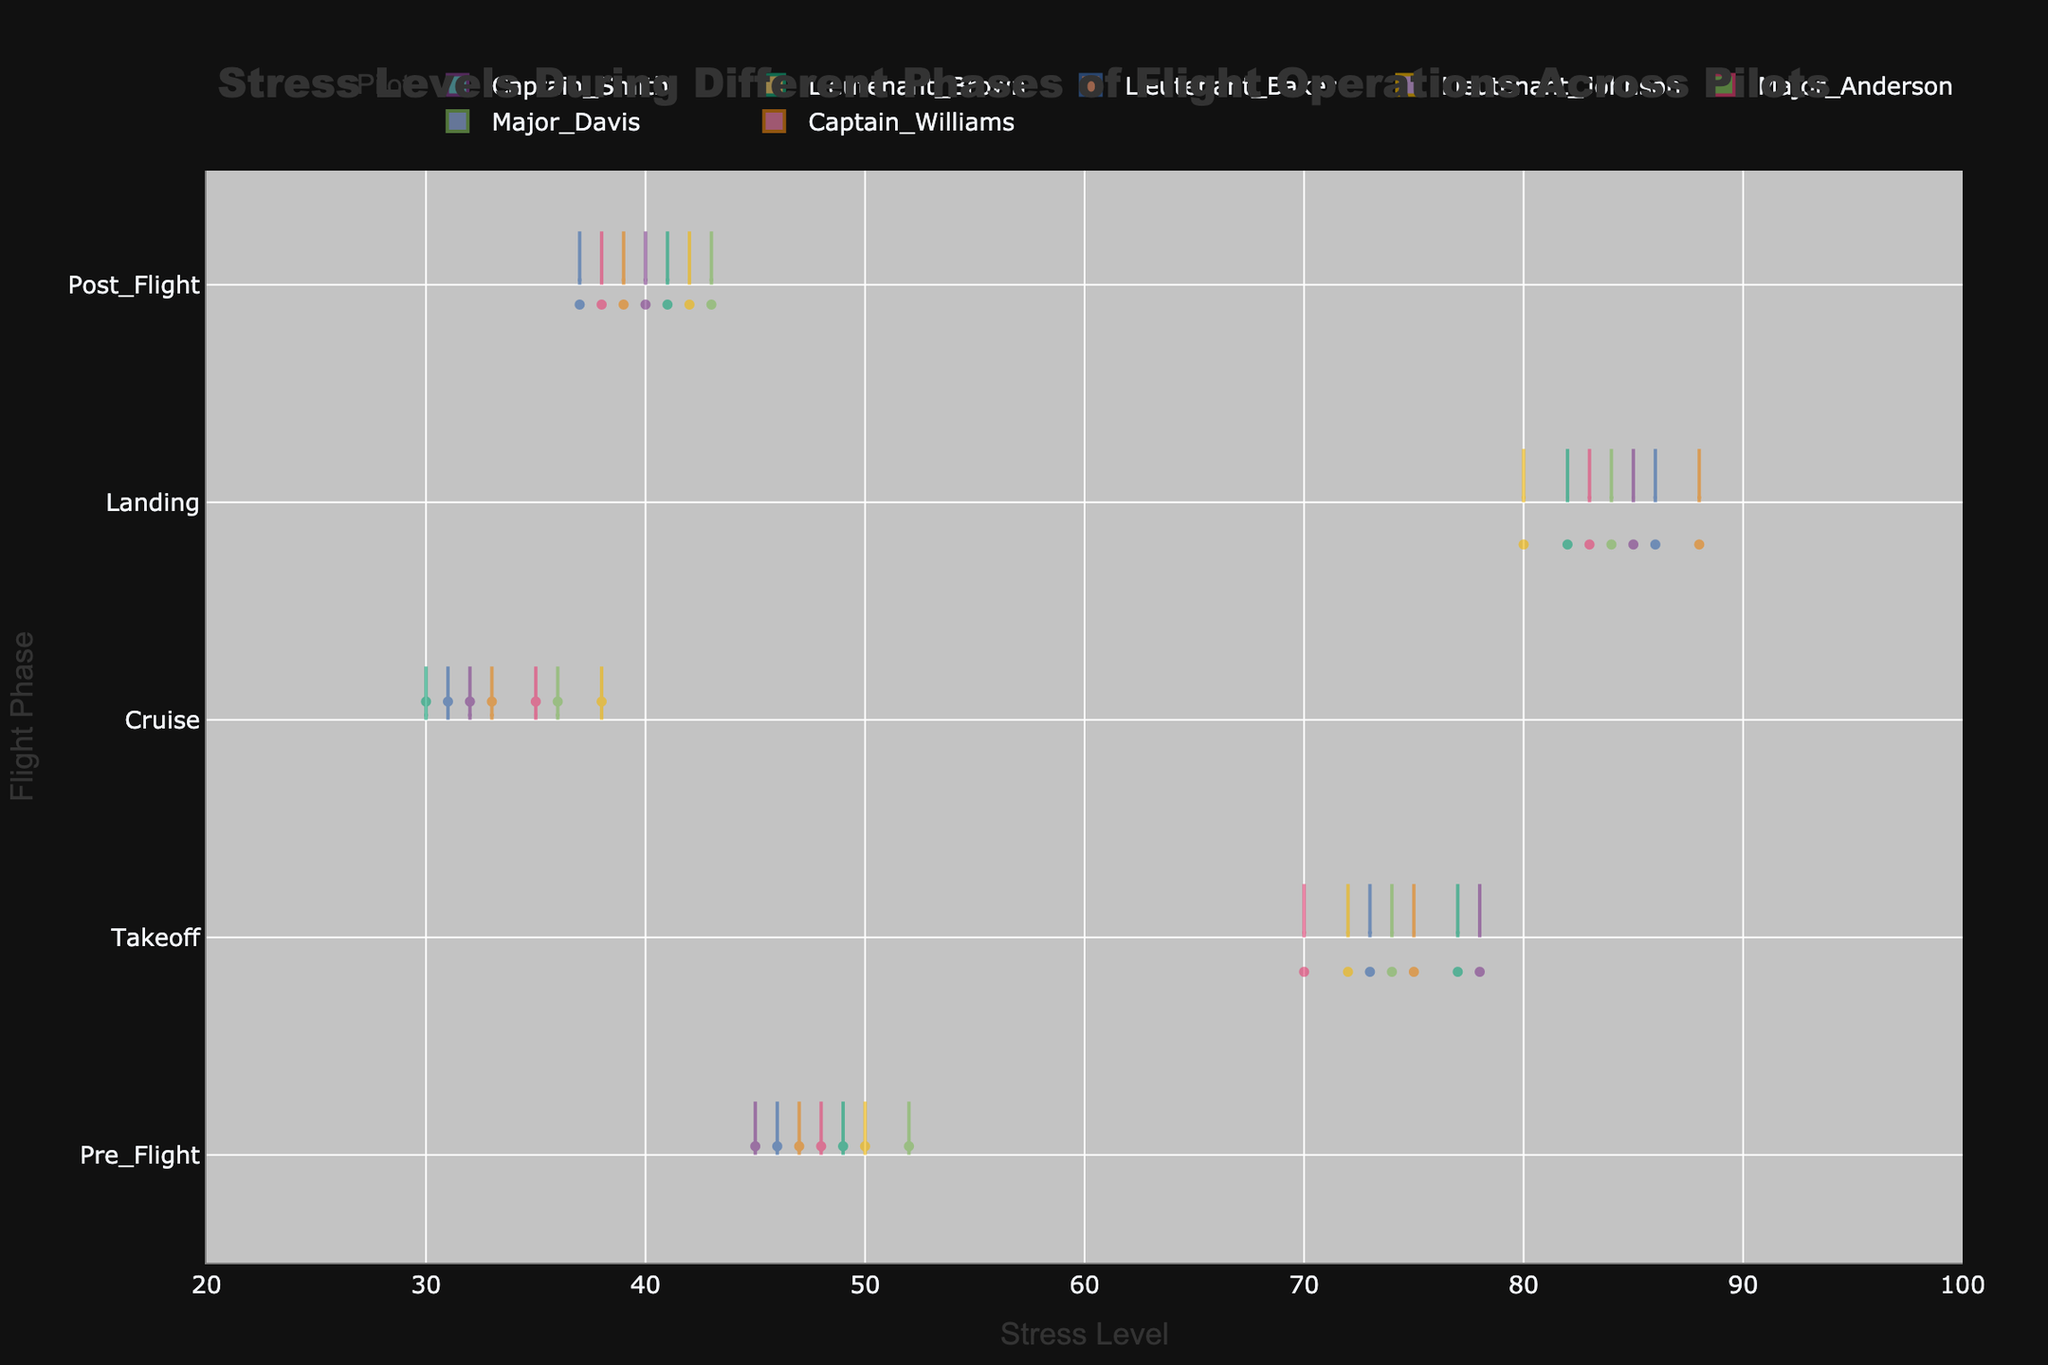What's the title of the figure? The title of any figure is usually at the top and helps the viewer understand the focus of the visualization. The title of the figure is "Stress Levels During Different Phases of Flight Operations Across Pilots."
Answer: Stress Levels During Different Phases of Flight Operations Across Pilots Which flight phase shows the highest median stress level across all pilots? Median stress levels can be compared by looking at the central mark of each phase's distribution for all pilots. The "Landing" phase consistently shows high central values in the violin plots.
Answer: Landing Which pilot has the lowest stress level during the Pre-Flight phase? To find this, examine the points in the "Pre_Flight" phase for all pilots. Major_Davis's data point shows the lowest value at 46.
Answer: Major_Davis What's the range of stress levels Captain_Williams experiences in the Landing phase? By observing the "Landing" phase for Captain_Williams, we see the points spread from the minimum to maximum values. These values are from 88 to 88, indicating no variation as the distribution is a single point.
Answer: 88-88 How many flight phases have a mean stress level above 70 for Captain_Smith? By examining the mean lines in the violin plots for Captain_Smith across all flight phases, we see that "Takeoff" and "Landing" have mean stress levels above 70, totaling 2 phases.
Answer: 2 Which flight phase has the most consistent (least spread) stress levels for all pilots? Consistency can be identified by observing phases with the smallest spread (narrowest violin shape). The "Cruise" phase appears to have the narrowest shapes, indicating the least spread.
Answer: Cruise Compare the stress levels of Major_Davis and Captain_Smith during the Post-Flight phase. Who experiences more stress? By looking at the points and distributions in the "Post_Flight" phase, Major_Davis has higher stress levels (43) compared to Captain_Smith (40).
Answer: Major_Davis Which pilot has the most variation in stress levels across different flight phases? Variation can be identified by examining the range of stress levels for each pilot's distributions across phases. Captain_Williams shows high variation, with stress levels ranging from 33 to 88.
Answer: Captain_Williams What's the average range of stress levels during the Takeoff phase for all pilots? To find the average range, calculate the range (max - min) for each pilot in the "Takeoff" phase and then find their average. For instance:
Captain_Smith: 78-78 = 0
Lieutenant_Johnson: 72-72 = 0
Major_Anderson: 70-70 = 0
Captain_Williams: 75-75 = 0
Lieutenant_Brown: 77-77 = 0
Major_Davis: 74-74 = 0
Lieutenant_Baker: 73-73 = 0
The average range = (0 + 0 + 0 + 0 + 0 + 0 + 0) / 7 = 0.
Answer: 0 